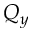Convert formula to latex. <formula><loc_0><loc_0><loc_500><loc_500>Q _ { y }</formula> 